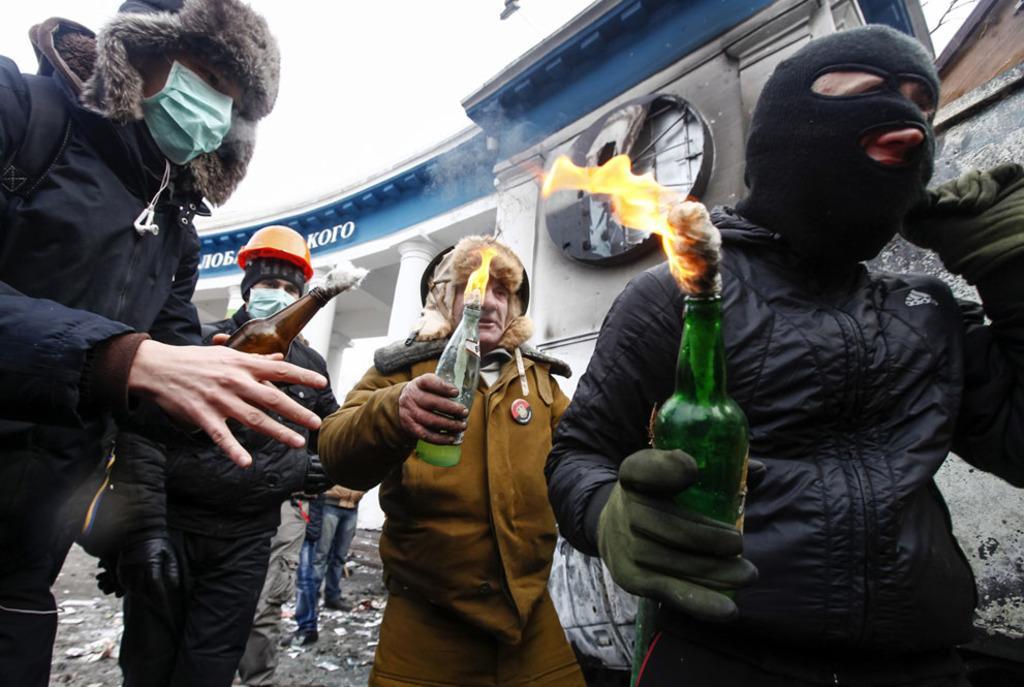Please provide a concise description of this image. This image is taken outdoors. In the background there is a building with walls, pillars, a roof and a door. At the bottom of the image there is a road. In the middle of the image there are four men with masks and they are holding bottles with fire in their hands. 